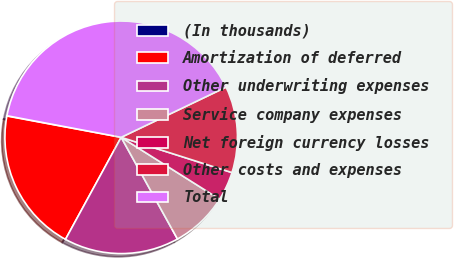<chart> <loc_0><loc_0><loc_500><loc_500><pie_chart><fcel>(In thousands)<fcel>Amortization of deferred<fcel>Other underwriting expenses<fcel>Service company expenses<fcel>Net foreign currency losses<fcel>Other costs and expenses<fcel>Total<nl><fcel>0.04%<fcel>19.98%<fcel>16.0%<fcel>8.02%<fcel>4.03%<fcel>12.01%<fcel>39.93%<nl></chart> 